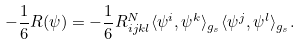Convert formula to latex. <formula><loc_0><loc_0><loc_500><loc_500>- \frac { 1 } { 6 } R ( \psi ) = - \frac { 1 } { 6 } R ^ { N } _ { i j k l } \langle \psi ^ { i } , \psi ^ { k } \rangle _ { g _ { s } } \langle \psi ^ { j } , \psi ^ { l } \rangle _ { g _ { s } } .</formula> 